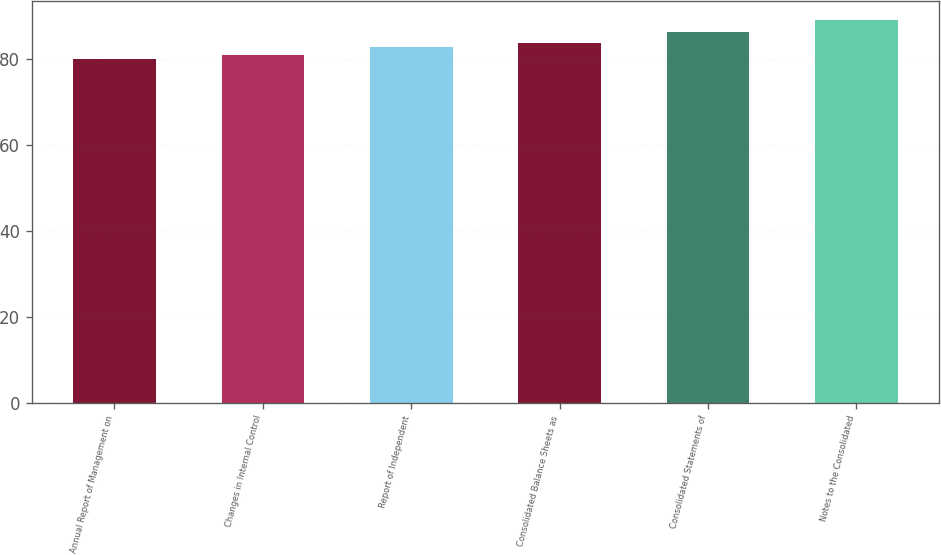Convert chart to OTSL. <chart><loc_0><loc_0><loc_500><loc_500><bar_chart><fcel>Annual Report of Management on<fcel>Changes in Internal Control<fcel>Report of Independent<fcel>Consolidated Balance Sheets as<fcel>Consolidated Statements of<fcel>Notes to the Consolidated<nl><fcel>80<fcel>80.9<fcel>82.7<fcel>83.6<fcel>86.3<fcel>89<nl></chart> 